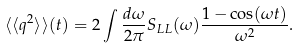Convert formula to latex. <formula><loc_0><loc_0><loc_500><loc_500>\langle \langle q ^ { 2 } \rangle \rangle ( t ) = 2 \int \frac { d \omega } { 2 \pi } S _ { L L } ( \omega ) \frac { 1 - \cos ( \omega t ) } { \omega ^ { 2 } } .</formula> 